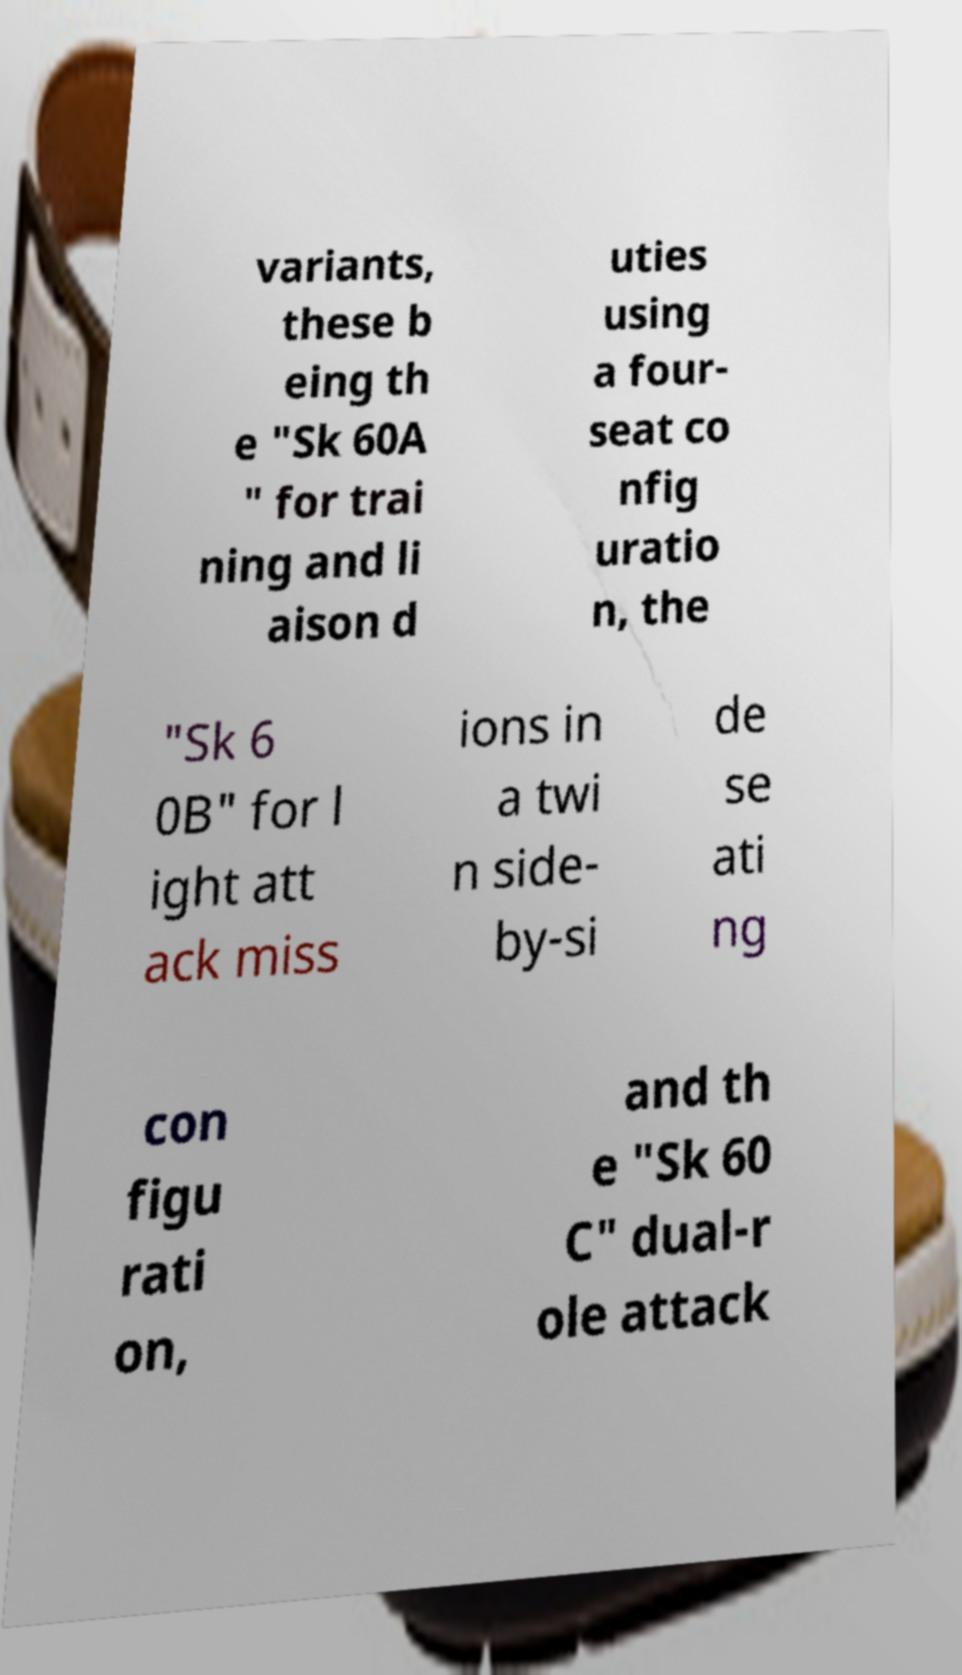Can you read and provide the text displayed in the image?This photo seems to have some interesting text. Can you extract and type it out for me? variants, these b eing th e "Sk 60A " for trai ning and li aison d uties using a four- seat co nfig uratio n, the "Sk 6 0B" for l ight att ack miss ions in a twi n side- by-si de se ati ng con figu rati on, and th e "Sk 60 C" dual-r ole attack 